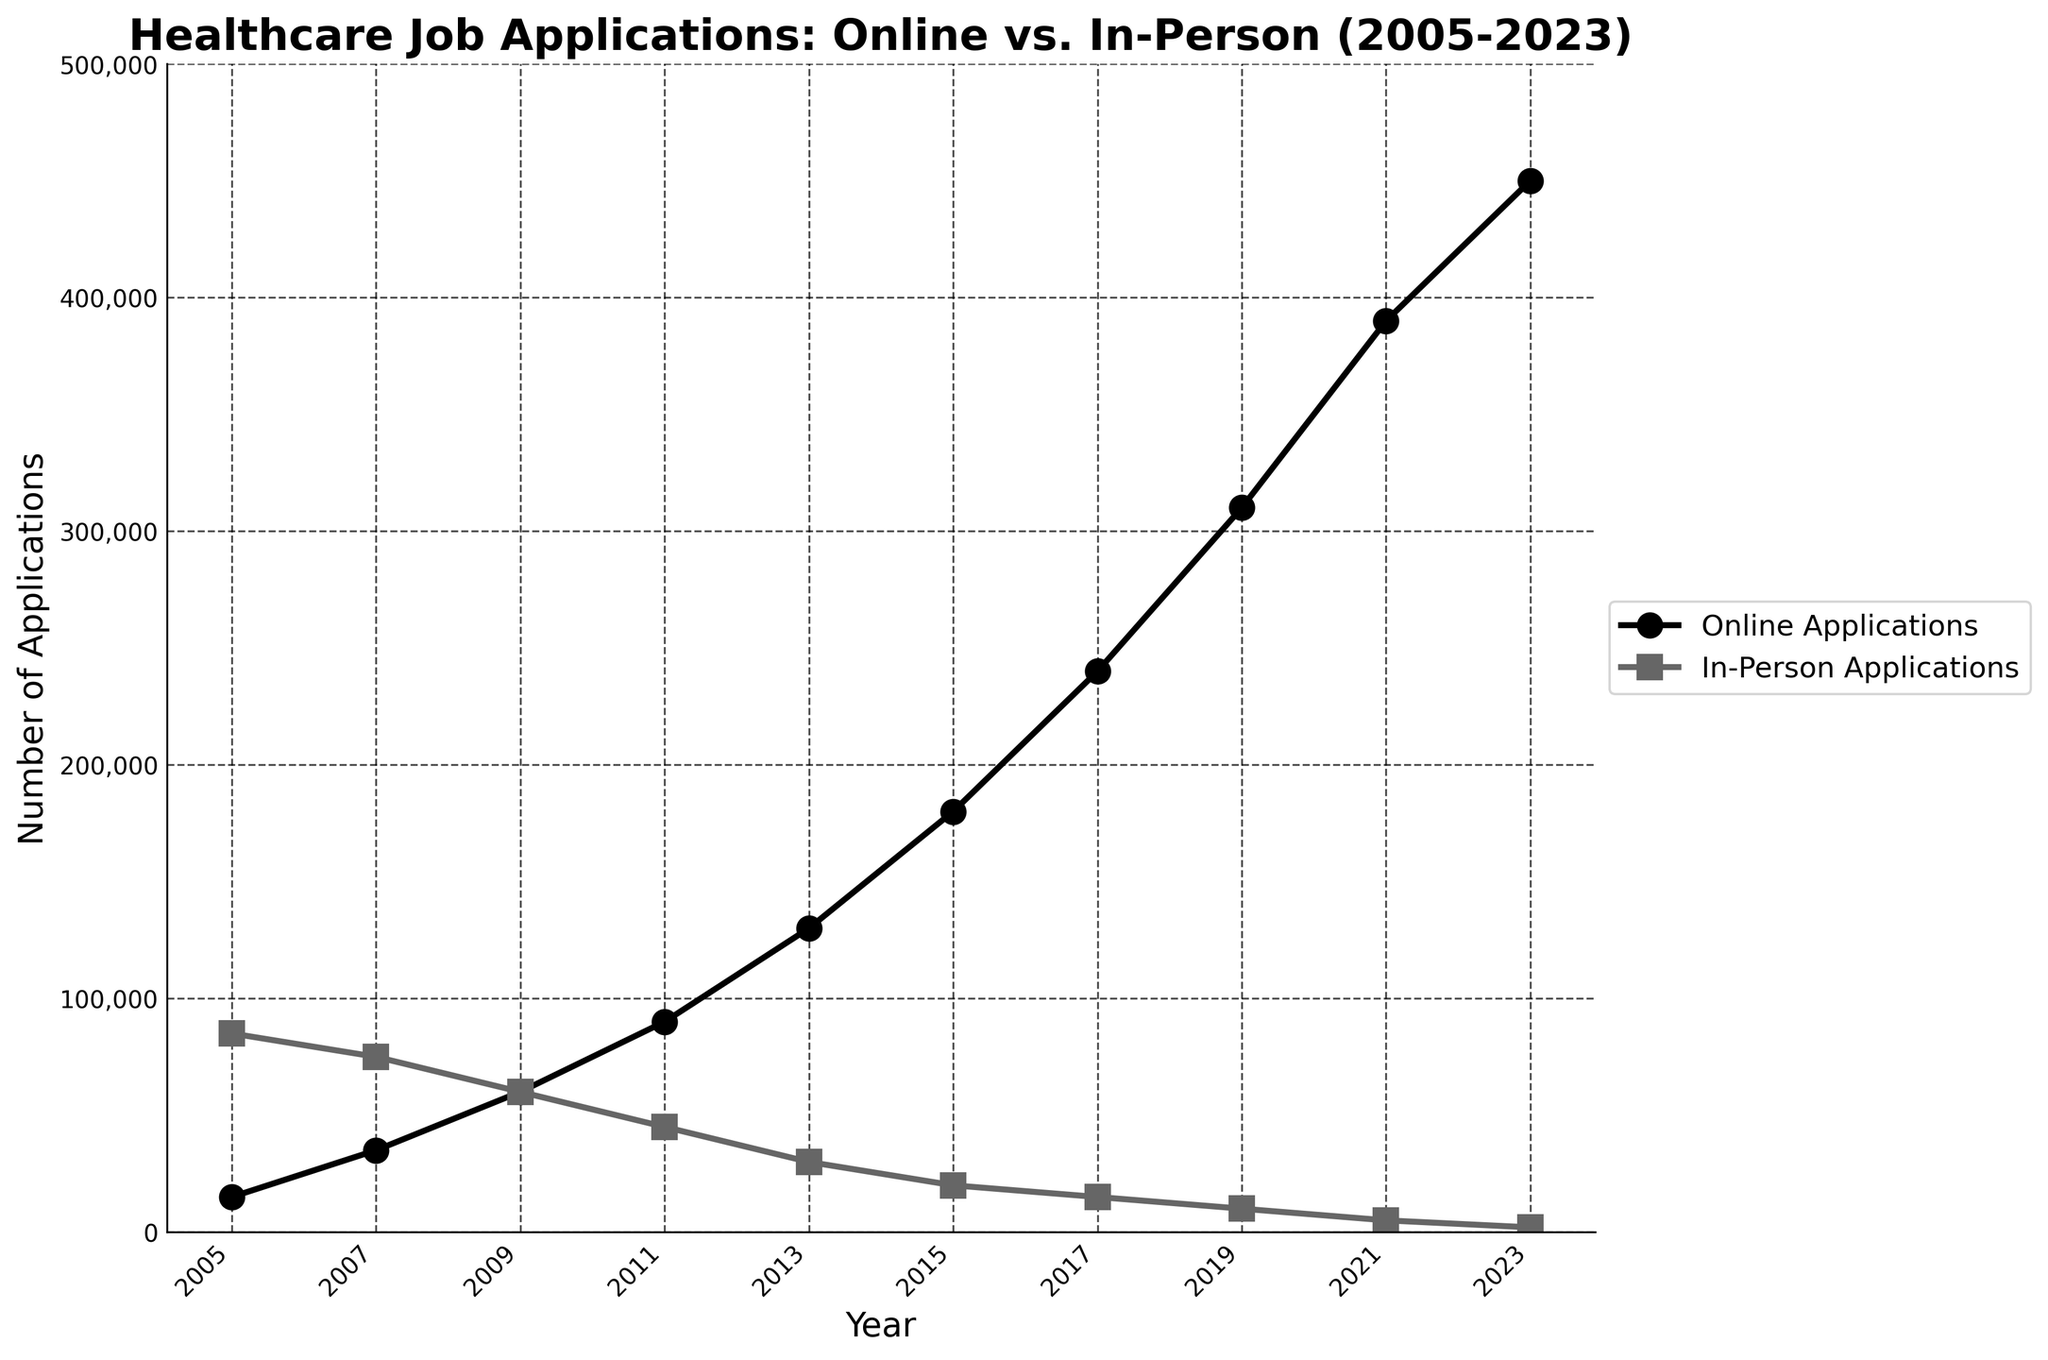What is the overall trend of online job applications from 2005 to 2023? The number of online job applications consistently increases from 15,000 in 2005 to 450,000 in 2023.
Answer: Increasing What is the overall trend of in-person job applications from 2005 to 2023? The number of in-person job applications steadily decreases from 85,000 in 2005 to 2,000 in 2023.
Answer: Decreasing In which year did online applications equal in-person applications? In 2009, both online and in-person job applications were 60,000, making them equal.
Answer: 2009 By how much did online applications increase from 2005 to 2023? The increase is calculated by subtracting the number of online applications in 2005 from that in 2023: 450,000 - 15,000 = 435,000.
Answer: 435,000 By how much did in-person applications decrease from 2005 to 2023? The decrease is calculated by subtracting the number of in-person applications in 2023 from that in 2005: 85,000 - 2,000 = 83,000.
Answer: 83,000 What is the difference in the number of online applications between 2011 and 2013? The difference is calculated by subtracting the number of online applications in 2011 from that in 2013: 130,000 - 90,000 = 40,000.
Answer: 40,000 Which year saw the highest number of online applications? By inspecting the line for online applications, 2023 had the highest number with 450,000 applications.
Answer: 2023 Which year saw the highest number of in-person applications? By inspecting the line for in-person applications, 2005 had the highest number with 85,000 applications.
Answer: 2005 How does the number of online applications in 2015 compare to that in-person in 2013? The number of online applications in 2015 (180,000) is significantly higher than in-person applications in 2013 (30,000).
Answer: Higher From 2017 to 2019, what is the average annual increase in online applications? Calculate the increase first (310,000 - 240,000 = 70,000) and then divide by 2 years to find the average annual increase: 70,000 / 2 = 35,000.
Answer: 35,000 